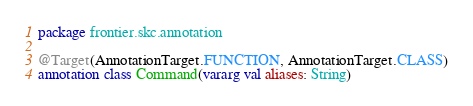<code> <loc_0><loc_0><loc_500><loc_500><_Kotlin_>package frontier.skc.annotation

@Target(AnnotationTarget.FUNCTION, AnnotationTarget.CLASS)
annotation class Command(vararg val aliases: String)
</code> 